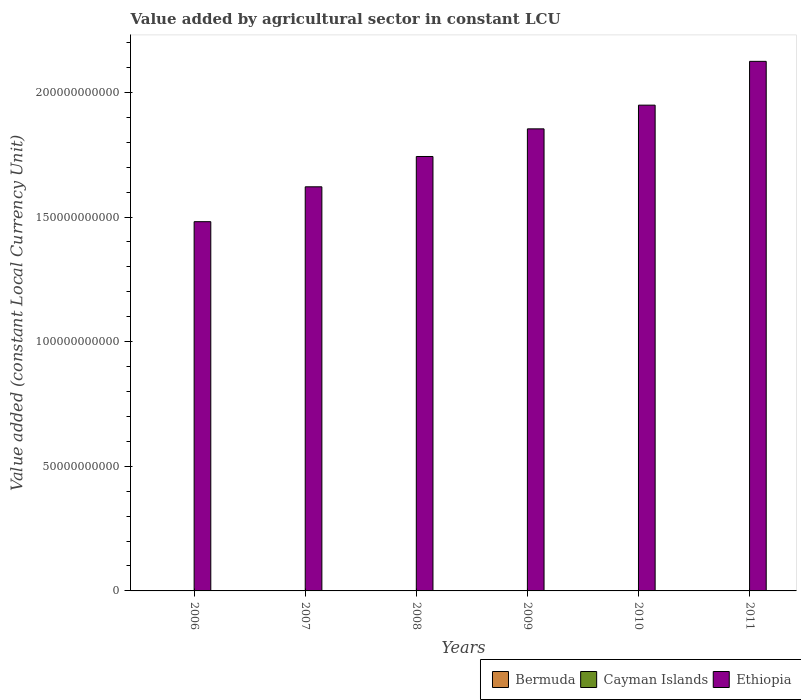How many different coloured bars are there?
Provide a short and direct response. 3. How many bars are there on the 6th tick from the right?
Ensure brevity in your answer.  3. What is the label of the 4th group of bars from the left?
Offer a terse response. 2009. What is the value added by agricultural sector in Ethiopia in 2007?
Your answer should be very brief. 1.62e+11. Across all years, what is the maximum value added by agricultural sector in Cayman Islands?
Your answer should be very brief. 9.08e+06. Across all years, what is the minimum value added by agricultural sector in Bermuda?
Your answer should be very brief. 4.60e+07. In which year was the value added by agricultural sector in Bermuda minimum?
Give a very brief answer. 2011. What is the total value added by agricultural sector in Bermuda in the graph?
Provide a short and direct response. 2.88e+08. What is the difference between the value added by agricultural sector in Ethiopia in 2006 and that in 2008?
Offer a very short reply. -2.62e+1. What is the difference between the value added by agricultural sector in Cayman Islands in 2011 and the value added by agricultural sector in Bermuda in 2007?
Give a very brief answer. -3.92e+07. What is the average value added by agricultural sector in Bermuda per year?
Your answer should be compact. 4.80e+07. In the year 2008, what is the difference between the value added by agricultural sector in Cayman Islands and value added by agricultural sector in Ethiopia?
Your answer should be compact. -1.74e+11. What is the ratio of the value added by agricultural sector in Ethiopia in 2007 to that in 2011?
Your answer should be compact. 0.76. What is the difference between the highest and the second highest value added by agricultural sector in Ethiopia?
Offer a very short reply. 1.76e+1. What is the difference between the highest and the lowest value added by agricultural sector in Bermuda?
Your answer should be compact. 4.93e+06. In how many years, is the value added by agricultural sector in Bermuda greater than the average value added by agricultural sector in Bermuda taken over all years?
Your answer should be compact. 3. What does the 3rd bar from the left in 2008 represents?
Your answer should be compact. Ethiopia. What does the 1st bar from the right in 2006 represents?
Make the answer very short. Ethiopia. Is it the case that in every year, the sum of the value added by agricultural sector in Cayman Islands and value added by agricultural sector in Ethiopia is greater than the value added by agricultural sector in Bermuda?
Provide a succinct answer. Yes. How many years are there in the graph?
Keep it short and to the point. 6. Are the values on the major ticks of Y-axis written in scientific E-notation?
Offer a very short reply. No. Does the graph contain any zero values?
Offer a terse response. No. Where does the legend appear in the graph?
Make the answer very short. Bottom right. How are the legend labels stacked?
Ensure brevity in your answer.  Horizontal. What is the title of the graph?
Your answer should be compact. Value added by agricultural sector in constant LCU. What is the label or title of the X-axis?
Give a very brief answer. Years. What is the label or title of the Y-axis?
Give a very brief answer. Value added (constant Local Currency Unit). What is the Value added (constant Local Currency Unit) in Bermuda in 2006?
Your response must be concise. 4.64e+07. What is the Value added (constant Local Currency Unit) in Cayman Islands in 2006?
Make the answer very short. 7.17e+06. What is the Value added (constant Local Currency Unit) in Ethiopia in 2006?
Your answer should be compact. 1.48e+11. What is the Value added (constant Local Currency Unit) in Bermuda in 2007?
Provide a short and direct response. 4.83e+07. What is the Value added (constant Local Currency Unit) in Cayman Islands in 2007?
Keep it short and to the point. 7.65e+06. What is the Value added (constant Local Currency Unit) of Ethiopia in 2007?
Ensure brevity in your answer.  1.62e+11. What is the Value added (constant Local Currency Unit) in Bermuda in 2008?
Ensure brevity in your answer.  5.09e+07. What is the Value added (constant Local Currency Unit) in Cayman Islands in 2008?
Your response must be concise. 8.07e+06. What is the Value added (constant Local Currency Unit) of Ethiopia in 2008?
Give a very brief answer. 1.74e+11. What is the Value added (constant Local Currency Unit) in Bermuda in 2009?
Offer a very short reply. 4.83e+07. What is the Value added (constant Local Currency Unit) in Cayman Islands in 2009?
Provide a short and direct response. 8.89e+06. What is the Value added (constant Local Currency Unit) of Ethiopia in 2009?
Ensure brevity in your answer.  1.85e+11. What is the Value added (constant Local Currency Unit) of Bermuda in 2010?
Offer a very short reply. 4.79e+07. What is the Value added (constant Local Currency Unit) in Cayman Islands in 2010?
Make the answer very short. 8.76e+06. What is the Value added (constant Local Currency Unit) in Ethiopia in 2010?
Ensure brevity in your answer.  1.95e+11. What is the Value added (constant Local Currency Unit) of Bermuda in 2011?
Ensure brevity in your answer.  4.60e+07. What is the Value added (constant Local Currency Unit) in Cayman Islands in 2011?
Offer a terse response. 9.08e+06. What is the Value added (constant Local Currency Unit) in Ethiopia in 2011?
Provide a succinct answer. 2.12e+11. Across all years, what is the maximum Value added (constant Local Currency Unit) in Bermuda?
Your response must be concise. 5.09e+07. Across all years, what is the maximum Value added (constant Local Currency Unit) in Cayman Islands?
Keep it short and to the point. 9.08e+06. Across all years, what is the maximum Value added (constant Local Currency Unit) of Ethiopia?
Offer a very short reply. 2.12e+11. Across all years, what is the minimum Value added (constant Local Currency Unit) of Bermuda?
Make the answer very short. 4.60e+07. Across all years, what is the minimum Value added (constant Local Currency Unit) in Cayman Islands?
Give a very brief answer. 7.17e+06. Across all years, what is the minimum Value added (constant Local Currency Unit) in Ethiopia?
Your answer should be compact. 1.48e+11. What is the total Value added (constant Local Currency Unit) of Bermuda in the graph?
Give a very brief answer. 2.88e+08. What is the total Value added (constant Local Currency Unit) of Cayman Islands in the graph?
Keep it short and to the point. 4.96e+07. What is the total Value added (constant Local Currency Unit) of Ethiopia in the graph?
Give a very brief answer. 1.08e+12. What is the difference between the Value added (constant Local Currency Unit) in Bermuda in 2006 and that in 2007?
Your answer should be compact. -1.89e+06. What is the difference between the Value added (constant Local Currency Unit) of Cayman Islands in 2006 and that in 2007?
Provide a succinct answer. -4.76e+05. What is the difference between the Value added (constant Local Currency Unit) in Ethiopia in 2006 and that in 2007?
Your answer should be very brief. -1.40e+1. What is the difference between the Value added (constant Local Currency Unit) in Bermuda in 2006 and that in 2008?
Your response must be concise. -4.51e+06. What is the difference between the Value added (constant Local Currency Unit) in Cayman Islands in 2006 and that in 2008?
Make the answer very short. -8.95e+05. What is the difference between the Value added (constant Local Currency Unit) in Ethiopia in 2006 and that in 2008?
Provide a succinct answer. -2.62e+1. What is the difference between the Value added (constant Local Currency Unit) in Bermuda in 2006 and that in 2009?
Ensure brevity in your answer.  -1.95e+06. What is the difference between the Value added (constant Local Currency Unit) of Cayman Islands in 2006 and that in 2009?
Make the answer very short. -1.72e+06. What is the difference between the Value added (constant Local Currency Unit) in Ethiopia in 2006 and that in 2009?
Keep it short and to the point. -3.72e+1. What is the difference between the Value added (constant Local Currency Unit) of Bermuda in 2006 and that in 2010?
Make the answer very short. -1.51e+06. What is the difference between the Value added (constant Local Currency Unit) of Cayman Islands in 2006 and that in 2010?
Offer a terse response. -1.59e+06. What is the difference between the Value added (constant Local Currency Unit) of Ethiopia in 2006 and that in 2010?
Ensure brevity in your answer.  -4.68e+1. What is the difference between the Value added (constant Local Currency Unit) in Bermuda in 2006 and that in 2011?
Offer a terse response. 4.26e+05. What is the difference between the Value added (constant Local Currency Unit) in Cayman Islands in 2006 and that in 2011?
Make the answer very short. -1.91e+06. What is the difference between the Value added (constant Local Currency Unit) in Ethiopia in 2006 and that in 2011?
Offer a very short reply. -6.43e+1. What is the difference between the Value added (constant Local Currency Unit) in Bermuda in 2007 and that in 2008?
Your response must be concise. -2.62e+06. What is the difference between the Value added (constant Local Currency Unit) of Cayman Islands in 2007 and that in 2008?
Keep it short and to the point. -4.19e+05. What is the difference between the Value added (constant Local Currency Unit) in Ethiopia in 2007 and that in 2008?
Ensure brevity in your answer.  -1.22e+1. What is the difference between the Value added (constant Local Currency Unit) of Bermuda in 2007 and that in 2009?
Your answer should be very brief. -6.30e+04. What is the difference between the Value added (constant Local Currency Unit) in Cayman Islands in 2007 and that in 2009?
Your response must be concise. -1.24e+06. What is the difference between the Value added (constant Local Currency Unit) in Ethiopia in 2007 and that in 2009?
Give a very brief answer. -2.33e+1. What is the difference between the Value added (constant Local Currency Unit) in Bermuda in 2007 and that in 2010?
Offer a very short reply. 3.84e+05. What is the difference between the Value added (constant Local Currency Unit) in Cayman Islands in 2007 and that in 2010?
Keep it short and to the point. -1.11e+06. What is the difference between the Value added (constant Local Currency Unit) in Ethiopia in 2007 and that in 2010?
Your answer should be very brief. -3.28e+1. What is the difference between the Value added (constant Local Currency Unit) of Bermuda in 2007 and that in 2011?
Make the answer very short. 2.32e+06. What is the difference between the Value added (constant Local Currency Unit) in Cayman Islands in 2007 and that in 2011?
Provide a succinct answer. -1.43e+06. What is the difference between the Value added (constant Local Currency Unit) in Ethiopia in 2007 and that in 2011?
Your answer should be very brief. -5.03e+1. What is the difference between the Value added (constant Local Currency Unit) of Bermuda in 2008 and that in 2009?
Make the answer very short. 2.55e+06. What is the difference between the Value added (constant Local Currency Unit) of Cayman Islands in 2008 and that in 2009?
Give a very brief answer. -8.25e+05. What is the difference between the Value added (constant Local Currency Unit) in Ethiopia in 2008 and that in 2009?
Your answer should be compact. -1.11e+1. What is the difference between the Value added (constant Local Currency Unit) in Bermuda in 2008 and that in 2010?
Ensure brevity in your answer.  3.00e+06. What is the difference between the Value added (constant Local Currency Unit) in Cayman Islands in 2008 and that in 2010?
Your response must be concise. -6.94e+05. What is the difference between the Value added (constant Local Currency Unit) in Ethiopia in 2008 and that in 2010?
Provide a short and direct response. -2.06e+1. What is the difference between the Value added (constant Local Currency Unit) of Bermuda in 2008 and that in 2011?
Your response must be concise. 4.93e+06. What is the difference between the Value added (constant Local Currency Unit) in Cayman Islands in 2008 and that in 2011?
Provide a short and direct response. -1.01e+06. What is the difference between the Value added (constant Local Currency Unit) in Ethiopia in 2008 and that in 2011?
Provide a succinct answer. -3.82e+1. What is the difference between the Value added (constant Local Currency Unit) in Bermuda in 2009 and that in 2010?
Provide a short and direct response. 4.47e+05. What is the difference between the Value added (constant Local Currency Unit) of Cayman Islands in 2009 and that in 2010?
Ensure brevity in your answer.  1.30e+05. What is the difference between the Value added (constant Local Currency Unit) of Ethiopia in 2009 and that in 2010?
Make the answer very short. -9.51e+09. What is the difference between the Value added (constant Local Currency Unit) of Bermuda in 2009 and that in 2011?
Provide a short and direct response. 2.38e+06. What is the difference between the Value added (constant Local Currency Unit) in Cayman Islands in 2009 and that in 2011?
Offer a terse response. -1.88e+05. What is the difference between the Value added (constant Local Currency Unit) of Ethiopia in 2009 and that in 2011?
Ensure brevity in your answer.  -2.71e+1. What is the difference between the Value added (constant Local Currency Unit) in Bermuda in 2010 and that in 2011?
Your answer should be very brief. 1.93e+06. What is the difference between the Value added (constant Local Currency Unit) in Cayman Islands in 2010 and that in 2011?
Your answer should be very brief. -3.18e+05. What is the difference between the Value added (constant Local Currency Unit) of Ethiopia in 2010 and that in 2011?
Provide a succinct answer. -1.76e+1. What is the difference between the Value added (constant Local Currency Unit) in Bermuda in 2006 and the Value added (constant Local Currency Unit) in Cayman Islands in 2007?
Your response must be concise. 3.87e+07. What is the difference between the Value added (constant Local Currency Unit) in Bermuda in 2006 and the Value added (constant Local Currency Unit) in Ethiopia in 2007?
Keep it short and to the point. -1.62e+11. What is the difference between the Value added (constant Local Currency Unit) of Cayman Islands in 2006 and the Value added (constant Local Currency Unit) of Ethiopia in 2007?
Your answer should be very brief. -1.62e+11. What is the difference between the Value added (constant Local Currency Unit) in Bermuda in 2006 and the Value added (constant Local Currency Unit) in Cayman Islands in 2008?
Your response must be concise. 3.83e+07. What is the difference between the Value added (constant Local Currency Unit) of Bermuda in 2006 and the Value added (constant Local Currency Unit) of Ethiopia in 2008?
Give a very brief answer. -1.74e+11. What is the difference between the Value added (constant Local Currency Unit) in Cayman Islands in 2006 and the Value added (constant Local Currency Unit) in Ethiopia in 2008?
Your response must be concise. -1.74e+11. What is the difference between the Value added (constant Local Currency Unit) in Bermuda in 2006 and the Value added (constant Local Currency Unit) in Cayman Islands in 2009?
Your response must be concise. 3.75e+07. What is the difference between the Value added (constant Local Currency Unit) in Bermuda in 2006 and the Value added (constant Local Currency Unit) in Ethiopia in 2009?
Give a very brief answer. -1.85e+11. What is the difference between the Value added (constant Local Currency Unit) in Cayman Islands in 2006 and the Value added (constant Local Currency Unit) in Ethiopia in 2009?
Offer a terse response. -1.85e+11. What is the difference between the Value added (constant Local Currency Unit) in Bermuda in 2006 and the Value added (constant Local Currency Unit) in Cayman Islands in 2010?
Offer a very short reply. 3.76e+07. What is the difference between the Value added (constant Local Currency Unit) of Bermuda in 2006 and the Value added (constant Local Currency Unit) of Ethiopia in 2010?
Provide a short and direct response. -1.95e+11. What is the difference between the Value added (constant Local Currency Unit) of Cayman Islands in 2006 and the Value added (constant Local Currency Unit) of Ethiopia in 2010?
Keep it short and to the point. -1.95e+11. What is the difference between the Value added (constant Local Currency Unit) in Bermuda in 2006 and the Value added (constant Local Currency Unit) in Cayman Islands in 2011?
Your response must be concise. 3.73e+07. What is the difference between the Value added (constant Local Currency Unit) of Bermuda in 2006 and the Value added (constant Local Currency Unit) of Ethiopia in 2011?
Your response must be concise. -2.12e+11. What is the difference between the Value added (constant Local Currency Unit) in Cayman Islands in 2006 and the Value added (constant Local Currency Unit) in Ethiopia in 2011?
Provide a short and direct response. -2.12e+11. What is the difference between the Value added (constant Local Currency Unit) in Bermuda in 2007 and the Value added (constant Local Currency Unit) in Cayman Islands in 2008?
Your response must be concise. 4.02e+07. What is the difference between the Value added (constant Local Currency Unit) of Bermuda in 2007 and the Value added (constant Local Currency Unit) of Ethiopia in 2008?
Keep it short and to the point. -1.74e+11. What is the difference between the Value added (constant Local Currency Unit) of Cayman Islands in 2007 and the Value added (constant Local Currency Unit) of Ethiopia in 2008?
Your answer should be compact. -1.74e+11. What is the difference between the Value added (constant Local Currency Unit) in Bermuda in 2007 and the Value added (constant Local Currency Unit) in Cayman Islands in 2009?
Your answer should be very brief. 3.94e+07. What is the difference between the Value added (constant Local Currency Unit) of Bermuda in 2007 and the Value added (constant Local Currency Unit) of Ethiopia in 2009?
Provide a short and direct response. -1.85e+11. What is the difference between the Value added (constant Local Currency Unit) of Cayman Islands in 2007 and the Value added (constant Local Currency Unit) of Ethiopia in 2009?
Your response must be concise. -1.85e+11. What is the difference between the Value added (constant Local Currency Unit) in Bermuda in 2007 and the Value added (constant Local Currency Unit) in Cayman Islands in 2010?
Keep it short and to the point. 3.95e+07. What is the difference between the Value added (constant Local Currency Unit) in Bermuda in 2007 and the Value added (constant Local Currency Unit) in Ethiopia in 2010?
Offer a very short reply. -1.95e+11. What is the difference between the Value added (constant Local Currency Unit) in Cayman Islands in 2007 and the Value added (constant Local Currency Unit) in Ethiopia in 2010?
Your answer should be compact. -1.95e+11. What is the difference between the Value added (constant Local Currency Unit) in Bermuda in 2007 and the Value added (constant Local Currency Unit) in Cayman Islands in 2011?
Provide a short and direct response. 3.92e+07. What is the difference between the Value added (constant Local Currency Unit) of Bermuda in 2007 and the Value added (constant Local Currency Unit) of Ethiopia in 2011?
Keep it short and to the point. -2.12e+11. What is the difference between the Value added (constant Local Currency Unit) of Cayman Islands in 2007 and the Value added (constant Local Currency Unit) of Ethiopia in 2011?
Provide a short and direct response. -2.12e+11. What is the difference between the Value added (constant Local Currency Unit) of Bermuda in 2008 and the Value added (constant Local Currency Unit) of Cayman Islands in 2009?
Your response must be concise. 4.20e+07. What is the difference between the Value added (constant Local Currency Unit) in Bermuda in 2008 and the Value added (constant Local Currency Unit) in Ethiopia in 2009?
Offer a terse response. -1.85e+11. What is the difference between the Value added (constant Local Currency Unit) of Cayman Islands in 2008 and the Value added (constant Local Currency Unit) of Ethiopia in 2009?
Ensure brevity in your answer.  -1.85e+11. What is the difference between the Value added (constant Local Currency Unit) in Bermuda in 2008 and the Value added (constant Local Currency Unit) in Cayman Islands in 2010?
Offer a very short reply. 4.21e+07. What is the difference between the Value added (constant Local Currency Unit) of Bermuda in 2008 and the Value added (constant Local Currency Unit) of Ethiopia in 2010?
Give a very brief answer. -1.95e+11. What is the difference between the Value added (constant Local Currency Unit) in Cayman Islands in 2008 and the Value added (constant Local Currency Unit) in Ethiopia in 2010?
Keep it short and to the point. -1.95e+11. What is the difference between the Value added (constant Local Currency Unit) in Bermuda in 2008 and the Value added (constant Local Currency Unit) in Cayman Islands in 2011?
Give a very brief answer. 4.18e+07. What is the difference between the Value added (constant Local Currency Unit) of Bermuda in 2008 and the Value added (constant Local Currency Unit) of Ethiopia in 2011?
Make the answer very short. -2.12e+11. What is the difference between the Value added (constant Local Currency Unit) of Cayman Islands in 2008 and the Value added (constant Local Currency Unit) of Ethiopia in 2011?
Your answer should be compact. -2.12e+11. What is the difference between the Value added (constant Local Currency Unit) in Bermuda in 2009 and the Value added (constant Local Currency Unit) in Cayman Islands in 2010?
Provide a succinct answer. 3.96e+07. What is the difference between the Value added (constant Local Currency Unit) in Bermuda in 2009 and the Value added (constant Local Currency Unit) in Ethiopia in 2010?
Offer a very short reply. -1.95e+11. What is the difference between the Value added (constant Local Currency Unit) in Cayman Islands in 2009 and the Value added (constant Local Currency Unit) in Ethiopia in 2010?
Offer a very short reply. -1.95e+11. What is the difference between the Value added (constant Local Currency Unit) of Bermuda in 2009 and the Value added (constant Local Currency Unit) of Cayman Islands in 2011?
Provide a short and direct response. 3.93e+07. What is the difference between the Value added (constant Local Currency Unit) of Bermuda in 2009 and the Value added (constant Local Currency Unit) of Ethiopia in 2011?
Offer a very short reply. -2.12e+11. What is the difference between the Value added (constant Local Currency Unit) of Cayman Islands in 2009 and the Value added (constant Local Currency Unit) of Ethiopia in 2011?
Give a very brief answer. -2.12e+11. What is the difference between the Value added (constant Local Currency Unit) in Bermuda in 2010 and the Value added (constant Local Currency Unit) in Cayman Islands in 2011?
Make the answer very short. 3.88e+07. What is the difference between the Value added (constant Local Currency Unit) in Bermuda in 2010 and the Value added (constant Local Currency Unit) in Ethiopia in 2011?
Your response must be concise. -2.12e+11. What is the difference between the Value added (constant Local Currency Unit) of Cayman Islands in 2010 and the Value added (constant Local Currency Unit) of Ethiopia in 2011?
Make the answer very short. -2.12e+11. What is the average Value added (constant Local Currency Unit) of Bermuda per year?
Provide a short and direct response. 4.80e+07. What is the average Value added (constant Local Currency Unit) in Cayman Islands per year?
Provide a succinct answer. 8.27e+06. What is the average Value added (constant Local Currency Unit) in Ethiopia per year?
Your answer should be very brief. 1.80e+11. In the year 2006, what is the difference between the Value added (constant Local Currency Unit) in Bermuda and Value added (constant Local Currency Unit) in Cayman Islands?
Make the answer very short. 3.92e+07. In the year 2006, what is the difference between the Value added (constant Local Currency Unit) of Bermuda and Value added (constant Local Currency Unit) of Ethiopia?
Provide a short and direct response. -1.48e+11. In the year 2006, what is the difference between the Value added (constant Local Currency Unit) in Cayman Islands and Value added (constant Local Currency Unit) in Ethiopia?
Provide a short and direct response. -1.48e+11. In the year 2007, what is the difference between the Value added (constant Local Currency Unit) in Bermuda and Value added (constant Local Currency Unit) in Cayman Islands?
Keep it short and to the point. 4.06e+07. In the year 2007, what is the difference between the Value added (constant Local Currency Unit) in Bermuda and Value added (constant Local Currency Unit) in Ethiopia?
Offer a terse response. -1.62e+11. In the year 2007, what is the difference between the Value added (constant Local Currency Unit) of Cayman Islands and Value added (constant Local Currency Unit) of Ethiopia?
Your answer should be very brief. -1.62e+11. In the year 2008, what is the difference between the Value added (constant Local Currency Unit) in Bermuda and Value added (constant Local Currency Unit) in Cayman Islands?
Offer a terse response. 4.28e+07. In the year 2008, what is the difference between the Value added (constant Local Currency Unit) of Bermuda and Value added (constant Local Currency Unit) of Ethiopia?
Give a very brief answer. -1.74e+11. In the year 2008, what is the difference between the Value added (constant Local Currency Unit) in Cayman Islands and Value added (constant Local Currency Unit) in Ethiopia?
Offer a very short reply. -1.74e+11. In the year 2009, what is the difference between the Value added (constant Local Currency Unit) of Bermuda and Value added (constant Local Currency Unit) of Cayman Islands?
Ensure brevity in your answer.  3.94e+07. In the year 2009, what is the difference between the Value added (constant Local Currency Unit) in Bermuda and Value added (constant Local Currency Unit) in Ethiopia?
Your response must be concise. -1.85e+11. In the year 2009, what is the difference between the Value added (constant Local Currency Unit) in Cayman Islands and Value added (constant Local Currency Unit) in Ethiopia?
Provide a short and direct response. -1.85e+11. In the year 2010, what is the difference between the Value added (constant Local Currency Unit) of Bermuda and Value added (constant Local Currency Unit) of Cayman Islands?
Provide a succinct answer. 3.91e+07. In the year 2010, what is the difference between the Value added (constant Local Currency Unit) of Bermuda and Value added (constant Local Currency Unit) of Ethiopia?
Give a very brief answer. -1.95e+11. In the year 2010, what is the difference between the Value added (constant Local Currency Unit) of Cayman Islands and Value added (constant Local Currency Unit) of Ethiopia?
Your response must be concise. -1.95e+11. In the year 2011, what is the difference between the Value added (constant Local Currency Unit) in Bermuda and Value added (constant Local Currency Unit) in Cayman Islands?
Keep it short and to the point. 3.69e+07. In the year 2011, what is the difference between the Value added (constant Local Currency Unit) in Bermuda and Value added (constant Local Currency Unit) in Ethiopia?
Ensure brevity in your answer.  -2.12e+11. In the year 2011, what is the difference between the Value added (constant Local Currency Unit) of Cayman Islands and Value added (constant Local Currency Unit) of Ethiopia?
Offer a terse response. -2.12e+11. What is the ratio of the Value added (constant Local Currency Unit) in Bermuda in 2006 to that in 2007?
Your answer should be compact. 0.96. What is the ratio of the Value added (constant Local Currency Unit) in Cayman Islands in 2006 to that in 2007?
Provide a succinct answer. 0.94. What is the ratio of the Value added (constant Local Currency Unit) of Ethiopia in 2006 to that in 2007?
Your answer should be very brief. 0.91. What is the ratio of the Value added (constant Local Currency Unit) of Bermuda in 2006 to that in 2008?
Provide a short and direct response. 0.91. What is the ratio of the Value added (constant Local Currency Unit) of Cayman Islands in 2006 to that in 2008?
Give a very brief answer. 0.89. What is the ratio of the Value added (constant Local Currency Unit) in Ethiopia in 2006 to that in 2008?
Give a very brief answer. 0.85. What is the ratio of the Value added (constant Local Currency Unit) of Bermuda in 2006 to that in 2009?
Offer a terse response. 0.96. What is the ratio of the Value added (constant Local Currency Unit) of Cayman Islands in 2006 to that in 2009?
Your answer should be very brief. 0.81. What is the ratio of the Value added (constant Local Currency Unit) in Ethiopia in 2006 to that in 2009?
Provide a short and direct response. 0.8. What is the ratio of the Value added (constant Local Currency Unit) in Bermuda in 2006 to that in 2010?
Offer a terse response. 0.97. What is the ratio of the Value added (constant Local Currency Unit) in Cayman Islands in 2006 to that in 2010?
Ensure brevity in your answer.  0.82. What is the ratio of the Value added (constant Local Currency Unit) in Ethiopia in 2006 to that in 2010?
Your response must be concise. 0.76. What is the ratio of the Value added (constant Local Currency Unit) of Bermuda in 2006 to that in 2011?
Your answer should be compact. 1.01. What is the ratio of the Value added (constant Local Currency Unit) of Cayman Islands in 2006 to that in 2011?
Your answer should be compact. 0.79. What is the ratio of the Value added (constant Local Currency Unit) in Ethiopia in 2006 to that in 2011?
Your answer should be very brief. 0.7. What is the ratio of the Value added (constant Local Currency Unit) in Bermuda in 2007 to that in 2008?
Your answer should be compact. 0.95. What is the ratio of the Value added (constant Local Currency Unit) of Cayman Islands in 2007 to that in 2008?
Provide a succinct answer. 0.95. What is the ratio of the Value added (constant Local Currency Unit) in Ethiopia in 2007 to that in 2008?
Your response must be concise. 0.93. What is the ratio of the Value added (constant Local Currency Unit) of Bermuda in 2007 to that in 2009?
Ensure brevity in your answer.  1. What is the ratio of the Value added (constant Local Currency Unit) in Cayman Islands in 2007 to that in 2009?
Ensure brevity in your answer.  0.86. What is the ratio of the Value added (constant Local Currency Unit) in Ethiopia in 2007 to that in 2009?
Your answer should be compact. 0.87. What is the ratio of the Value added (constant Local Currency Unit) in Cayman Islands in 2007 to that in 2010?
Your answer should be compact. 0.87. What is the ratio of the Value added (constant Local Currency Unit) of Ethiopia in 2007 to that in 2010?
Make the answer very short. 0.83. What is the ratio of the Value added (constant Local Currency Unit) of Bermuda in 2007 to that in 2011?
Offer a terse response. 1.05. What is the ratio of the Value added (constant Local Currency Unit) of Cayman Islands in 2007 to that in 2011?
Offer a terse response. 0.84. What is the ratio of the Value added (constant Local Currency Unit) in Ethiopia in 2007 to that in 2011?
Keep it short and to the point. 0.76. What is the ratio of the Value added (constant Local Currency Unit) in Bermuda in 2008 to that in 2009?
Provide a short and direct response. 1.05. What is the ratio of the Value added (constant Local Currency Unit) of Cayman Islands in 2008 to that in 2009?
Provide a succinct answer. 0.91. What is the ratio of the Value added (constant Local Currency Unit) of Ethiopia in 2008 to that in 2009?
Ensure brevity in your answer.  0.94. What is the ratio of the Value added (constant Local Currency Unit) of Bermuda in 2008 to that in 2010?
Provide a short and direct response. 1.06. What is the ratio of the Value added (constant Local Currency Unit) of Cayman Islands in 2008 to that in 2010?
Provide a short and direct response. 0.92. What is the ratio of the Value added (constant Local Currency Unit) of Ethiopia in 2008 to that in 2010?
Ensure brevity in your answer.  0.89. What is the ratio of the Value added (constant Local Currency Unit) in Bermuda in 2008 to that in 2011?
Provide a short and direct response. 1.11. What is the ratio of the Value added (constant Local Currency Unit) in Cayman Islands in 2008 to that in 2011?
Offer a terse response. 0.89. What is the ratio of the Value added (constant Local Currency Unit) of Ethiopia in 2008 to that in 2011?
Keep it short and to the point. 0.82. What is the ratio of the Value added (constant Local Currency Unit) of Bermuda in 2009 to that in 2010?
Give a very brief answer. 1.01. What is the ratio of the Value added (constant Local Currency Unit) in Cayman Islands in 2009 to that in 2010?
Provide a succinct answer. 1.01. What is the ratio of the Value added (constant Local Currency Unit) in Ethiopia in 2009 to that in 2010?
Ensure brevity in your answer.  0.95. What is the ratio of the Value added (constant Local Currency Unit) of Bermuda in 2009 to that in 2011?
Your answer should be very brief. 1.05. What is the ratio of the Value added (constant Local Currency Unit) in Cayman Islands in 2009 to that in 2011?
Your answer should be compact. 0.98. What is the ratio of the Value added (constant Local Currency Unit) in Ethiopia in 2009 to that in 2011?
Give a very brief answer. 0.87. What is the ratio of the Value added (constant Local Currency Unit) of Bermuda in 2010 to that in 2011?
Give a very brief answer. 1.04. What is the ratio of the Value added (constant Local Currency Unit) in Cayman Islands in 2010 to that in 2011?
Your response must be concise. 0.96. What is the ratio of the Value added (constant Local Currency Unit) of Ethiopia in 2010 to that in 2011?
Ensure brevity in your answer.  0.92. What is the difference between the highest and the second highest Value added (constant Local Currency Unit) in Bermuda?
Provide a short and direct response. 2.55e+06. What is the difference between the highest and the second highest Value added (constant Local Currency Unit) of Cayman Islands?
Your response must be concise. 1.88e+05. What is the difference between the highest and the second highest Value added (constant Local Currency Unit) of Ethiopia?
Your answer should be compact. 1.76e+1. What is the difference between the highest and the lowest Value added (constant Local Currency Unit) in Bermuda?
Your answer should be compact. 4.93e+06. What is the difference between the highest and the lowest Value added (constant Local Currency Unit) of Cayman Islands?
Your answer should be very brief. 1.91e+06. What is the difference between the highest and the lowest Value added (constant Local Currency Unit) in Ethiopia?
Make the answer very short. 6.43e+1. 